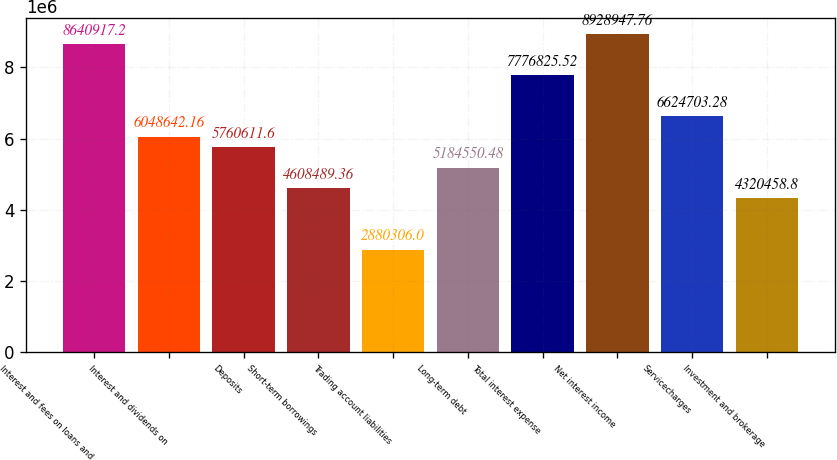<chart> <loc_0><loc_0><loc_500><loc_500><bar_chart><fcel>Interest and fees on loans and<fcel>Interest and dividends on<fcel>Deposits<fcel>Short-term borrowings<fcel>Trading account liabilities<fcel>Long-term debt<fcel>Total interest expense<fcel>Net interest income<fcel>Servicecharges<fcel>Investment and brokerage<nl><fcel>8.64092e+06<fcel>6.04864e+06<fcel>5.76061e+06<fcel>4.60849e+06<fcel>2.88031e+06<fcel>5.18455e+06<fcel>7.77683e+06<fcel>8.92895e+06<fcel>6.6247e+06<fcel>4.32046e+06<nl></chart> 